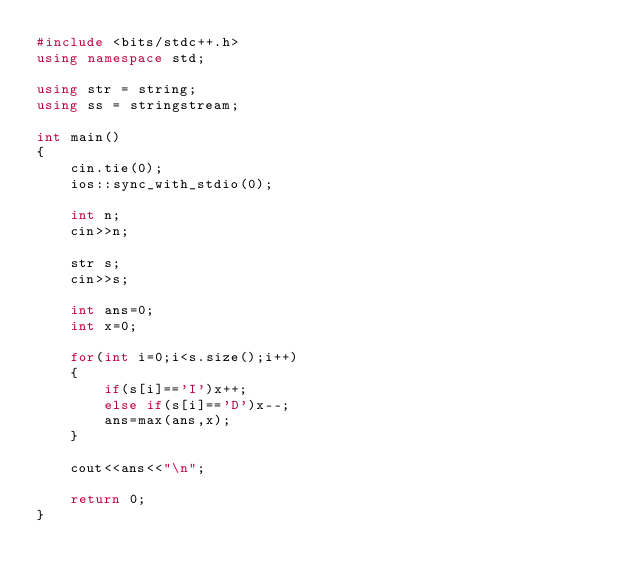<code> <loc_0><loc_0><loc_500><loc_500><_C++_>#include <bits/stdc++.h>
using namespace std;

using str = string;
using ss = stringstream;

int main()
{
    cin.tie(0);
    ios::sync_with_stdio(0);

    int n;
    cin>>n;

    str s;
    cin>>s;

    int ans=0;
    int x=0;

    for(int i=0;i<s.size();i++)
    {
        if(s[i]=='I')x++;
        else if(s[i]=='D')x--;
        ans=max(ans,x);
    }

    cout<<ans<<"\n";

    return 0;
}
</code> 